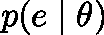Convert formula to latex. <formula><loc_0><loc_0><loc_500><loc_500>p ( e | \theta )</formula> 